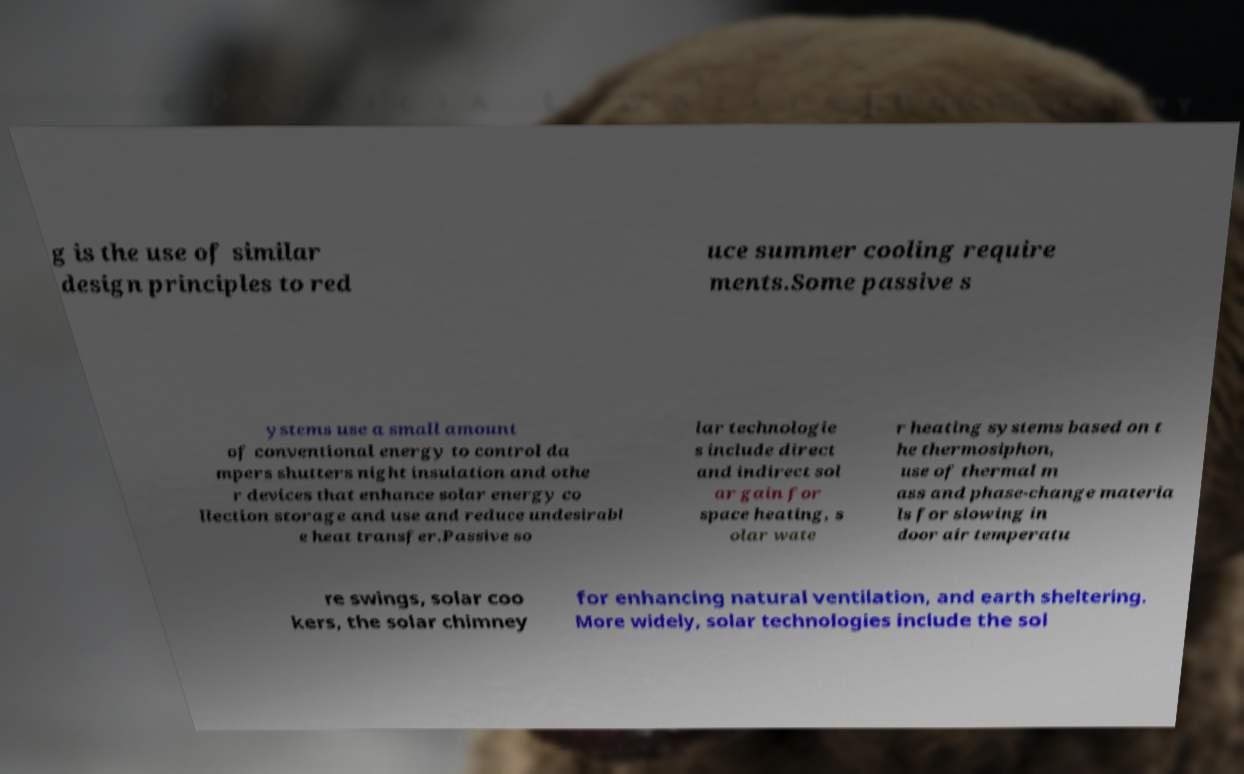I need the written content from this picture converted into text. Can you do that? g is the use of similar design principles to red uce summer cooling require ments.Some passive s ystems use a small amount of conventional energy to control da mpers shutters night insulation and othe r devices that enhance solar energy co llection storage and use and reduce undesirabl e heat transfer.Passive so lar technologie s include direct and indirect sol ar gain for space heating, s olar wate r heating systems based on t he thermosiphon, use of thermal m ass and phase-change materia ls for slowing in door air temperatu re swings, solar coo kers, the solar chimney for enhancing natural ventilation, and earth sheltering. More widely, solar technologies include the sol 